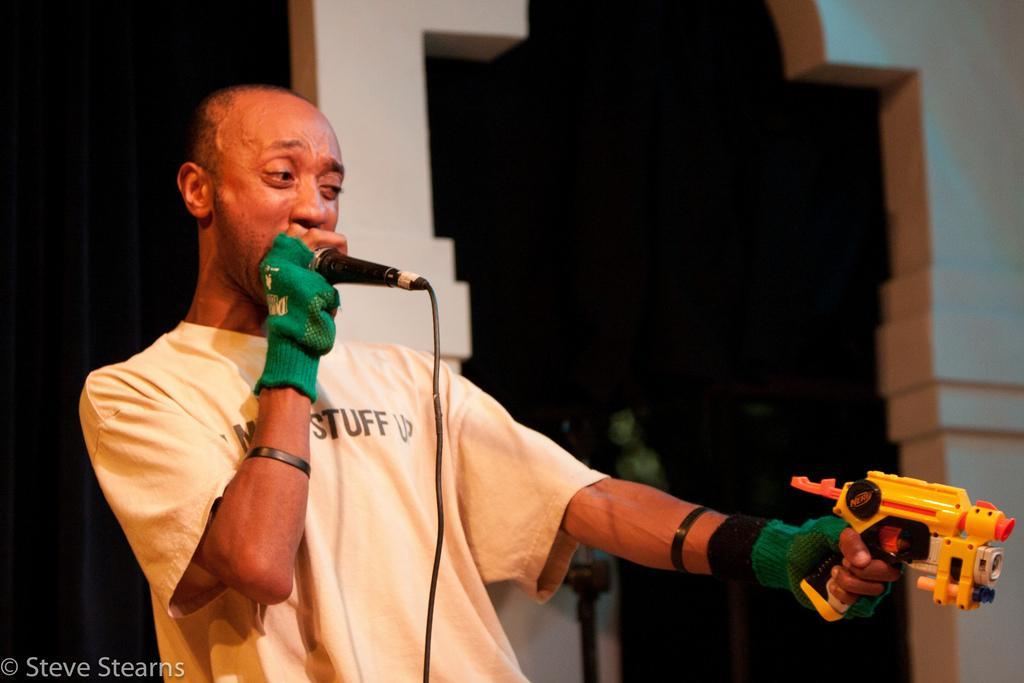Could you give a brief overview of what you see in this image? In this image I can see a man standing. There is a mic,man is wearing gloves. At the background we can see a wall and there is a black curtain. The man is holding a toy gun. 